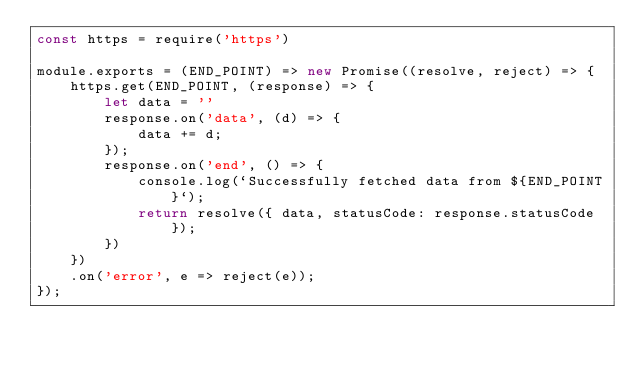<code> <loc_0><loc_0><loc_500><loc_500><_JavaScript_>const https = require('https')

module.exports = (END_POINT) => new Promise((resolve, reject) => {
    https.get(END_POINT, (response) => {
        let data = ''
        response.on('data', (d) => {
            data += d;
        });
        response.on('end', () => {
            console.log(`Successfully fetched data from ${END_POINT}`);
            return resolve({ data, statusCode: response.statusCode });
        })
    })
    .on('error', e => reject(e));
});
</code> 